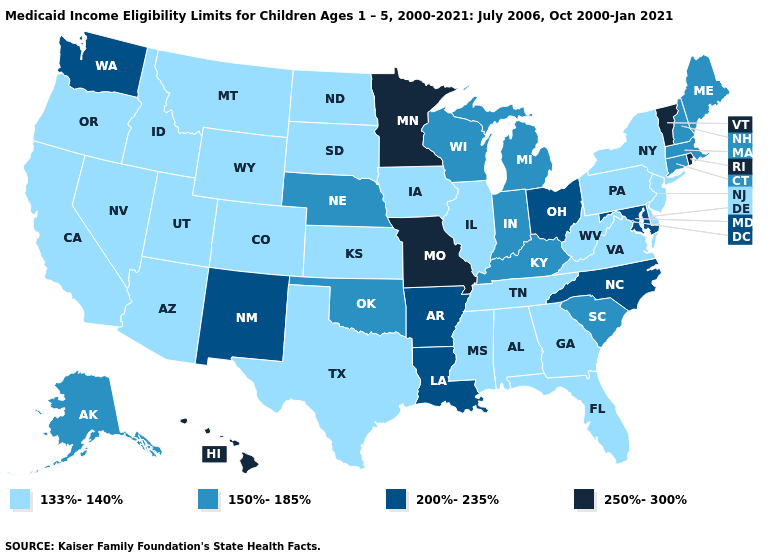Does Arizona have the lowest value in the USA?
Keep it brief. Yes. What is the lowest value in the USA?
Write a very short answer. 133%-140%. What is the lowest value in the MidWest?
Answer briefly. 133%-140%. What is the highest value in the South ?
Answer briefly. 200%-235%. What is the highest value in the West ?
Concise answer only. 250%-300%. Name the states that have a value in the range 150%-185%?
Concise answer only. Alaska, Connecticut, Indiana, Kentucky, Maine, Massachusetts, Michigan, Nebraska, New Hampshire, Oklahoma, South Carolina, Wisconsin. Name the states that have a value in the range 133%-140%?
Quick response, please. Alabama, Arizona, California, Colorado, Delaware, Florida, Georgia, Idaho, Illinois, Iowa, Kansas, Mississippi, Montana, Nevada, New Jersey, New York, North Dakota, Oregon, Pennsylvania, South Dakota, Tennessee, Texas, Utah, Virginia, West Virginia, Wyoming. Name the states that have a value in the range 200%-235%?
Quick response, please. Arkansas, Louisiana, Maryland, New Mexico, North Carolina, Ohio, Washington. What is the value of Kansas?
Answer briefly. 133%-140%. Which states have the highest value in the USA?
Be succinct. Hawaii, Minnesota, Missouri, Rhode Island, Vermont. What is the lowest value in states that border New Mexico?
Write a very short answer. 133%-140%. What is the value of Idaho?
Write a very short answer. 133%-140%. Which states have the lowest value in the MidWest?
Concise answer only. Illinois, Iowa, Kansas, North Dakota, South Dakota. What is the value of Georgia?
Give a very brief answer. 133%-140%. 